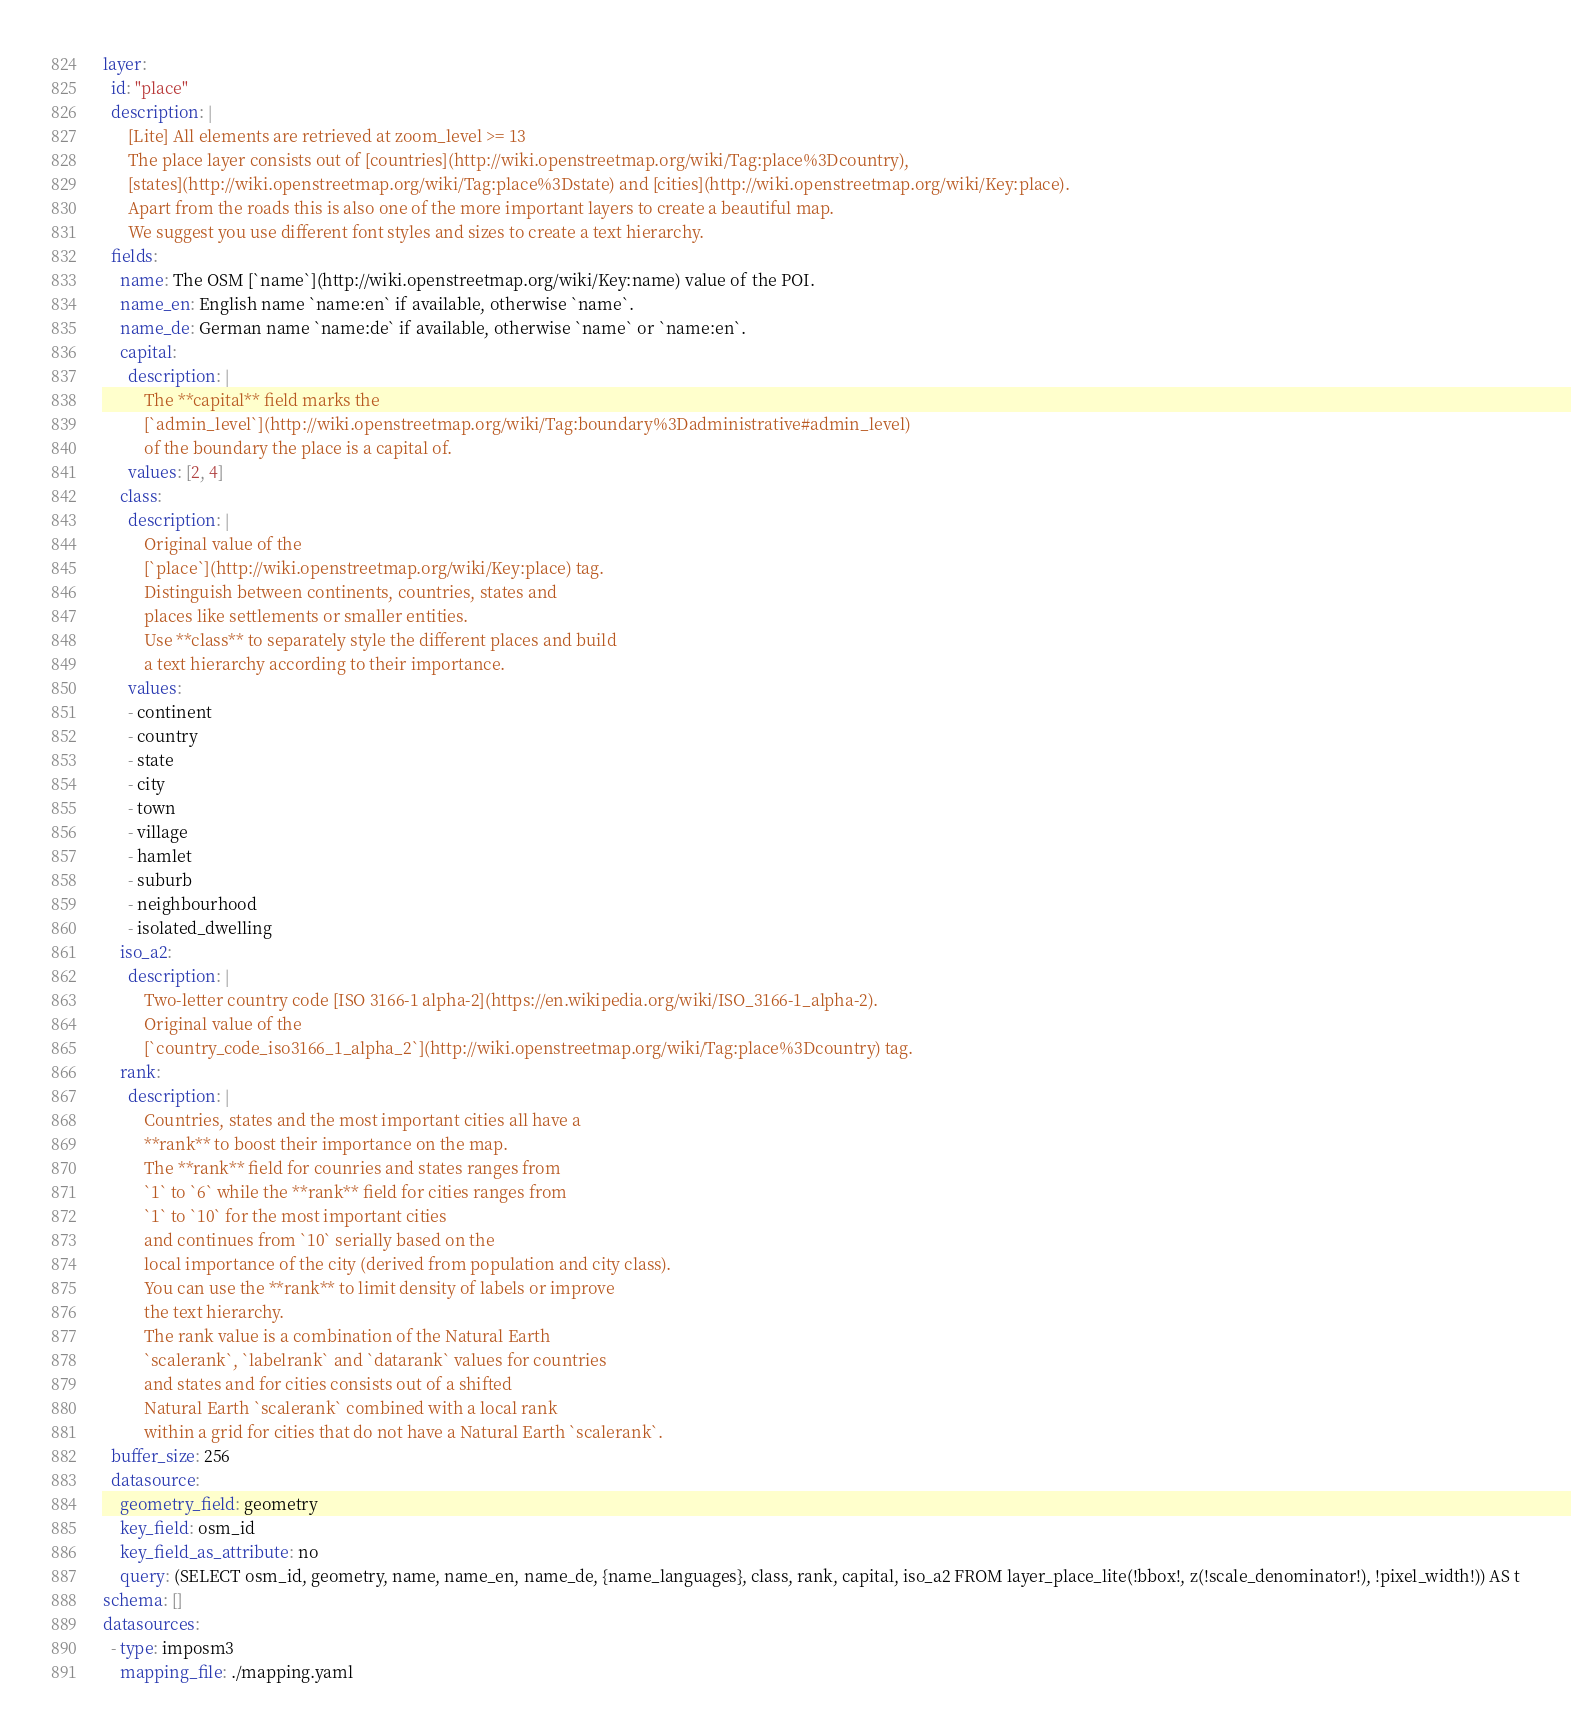<code> <loc_0><loc_0><loc_500><loc_500><_YAML_>layer:
  id: "place"
  description: |
      [Lite] All elements are retrieved at zoom_level >= 13
      The place layer consists out of [countries](http://wiki.openstreetmap.org/wiki/Tag:place%3Dcountry),
      [states](http://wiki.openstreetmap.org/wiki/Tag:place%3Dstate) and [cities](http://wiki.openstreetmap.org/wiki/Key:place).
      Apart from the roads this is also one of the more important layers to create a beautiful map.
      We suggest you use different font styles and sizes to create a text hierarchy.
  fields:
    name: The OSM [`name`](http://wiki.openstreetmap.org/wiki/Key:name) value of the POI.
    name_en: English name `name:en` if available, otherwise `name`.
    name_de: German name `name:de` if available, otherwise `name` or `name:en`.
    capital:
      description: |
          The **capital** field marks the
          [`admin_level`](http://wiki.openstreetmap.org/wiki/Tag:boundary%3Dadministrative#admin_level)
          of the boundary the place is a capital of.
      values: [2, 4]
    class:
      description: |
          Original value of the
          [`place`](http://wiki.openstreetmap.org/wiki/Key:place) tag.
          Distinguish between continents, countries, states and
          places like settlements or smaller entities.
          Use **class** to separately style the different places and build
          a text hierarchy according to their importance.
      values:
      - continent
      - country
      - state
      - city
      - town
      - village
      - hamlet
      - suburb
      - neighbourhood
      - isolated_dwelling
    iso_a2:
      description: |
          Two-letter country code [ISO 3166-1 alpha-2](https://en.wikipedia.org/wiki/ISO_3166-1_alpha-2).
          Original value of the
          [`country_code_iso3166_1_alpha_2`](http://wiki.openstreetmap.org/wiki/Tag:place%3Dcountry) tag.
    rank:
      description: |
          Countries, states and the most important cities all have a
          **rank** to boost their importance on the map.
          The **rank** field for counries and states ranges from
          `1` to `6` while the **rank** field for cities ranges from
          `1` to `10` for the most important cities
          and continues from `10` serially based on the
          local importance of the city (derived from population and city class).
          You can use the **rank** to limit density of labels or improve
          the text hierarchy.
          The rank value is a combination of the Natural Earth
          `scalerank`, `labelrank` and `datarank` values for countries
          and states and for cities consists out of a shifted
          Natural Earth `scalerank` combined with a local rank
          within a grid for cities that do not have a Natural Earth `scalerank`.
  buffer_size: 256
  datasource:
    geometry_field: geometry
    key_field: osm_id
    key_field_as_attribute: no
    query: (SELECT osm_id, geometry, name, name_en, name_de, {name_languages}, class, rank, capital, iso_a2 FROM layer_place_lite(!bbox!, z(!scale_denominator!), !pixel_width!)) AS t
schema: []
datasources:
  - type: imposm3
    mapping_file: ./mapping.yaml
</code> 